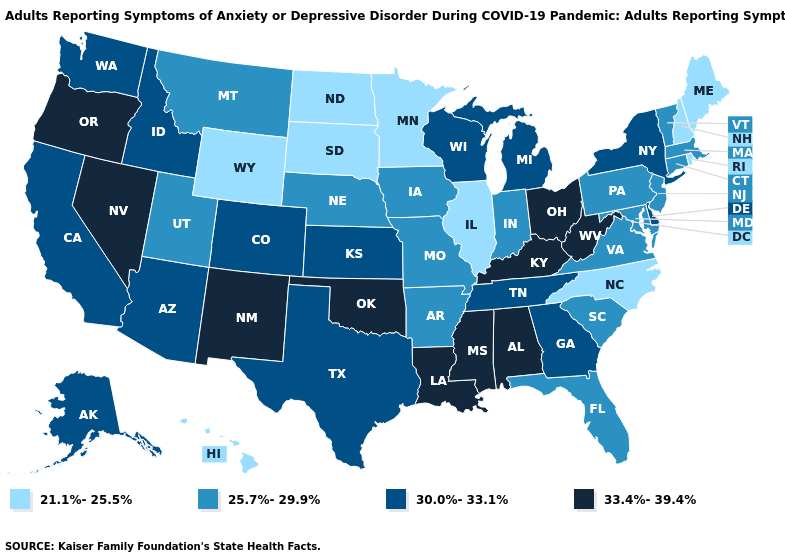What is the lowest value in the USA?
Keep it brief. 21.1%-25.5%. Name the states that have a value in the range 30.0%-33.1%?
Keep it brief. Alaska, Arizona, California, Colorado, Delaware, Georgia, Idaho, Kansas, Michigan, New York, Tennessee, Texas, Washington, Wisconsin. Does the map have missing data?
Answer briefly. No. Among the states that border Arkansas , does Oklahoma have the highest value?
Concise answer only. Yes. Does the map have missing data?
Give a very brief answer. No. What is the value of Missouri?
Write a very short answer. 25.7%-29.9%. How many symbols are there in the legend?
Keep it brief. 4. Name the states that have a value in the range 30.0%-33.1%?
Give a very brief answer. Alaska, Arizona, California, Colorado, Delaware, Georgia, Idaho, Kansas, Michigan, New York, Tennessee, Texas, Washington, Wisconsin. What is the lowest value in states that border New Jersey?
Keep it brief. 25.7%-29.9%. Name the states that have a value in the range 21.1%-25.5%?
Be succinct. Hawaii, Illinois, Maine, Minnesota, New Hampshire, North Carolina, North Dakota, Rhode Island, South Dakota, Wyoming. Does South Carolina have the highest value in the USA?
Keep it brief. No. What is the lowest value in states that border Kentucky?
Concise answer only. 21.1%-25.5%. Does the map have missing data?
Be succinct. No. Does the map have missing data?
Answer briefly. No. Does New Hampshire have the lowest value in the Northeast?
Give a very brief answer. Yes. 